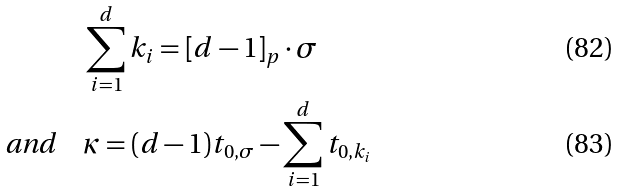<formula> <loc_0><loc_0><loc_500><loc_500>& \sum _ { i = 1 } ^ { d } k _ { i } = [ d - 1 ] _ { p } \cdot \sigma \\ \text {and} \quad & \kappa = ( d - 1 ) t _ { 0 , \sigma } - \sum _ { i = 1 } ^ { d } t _ { 0 , k _ { i } }</formula> 